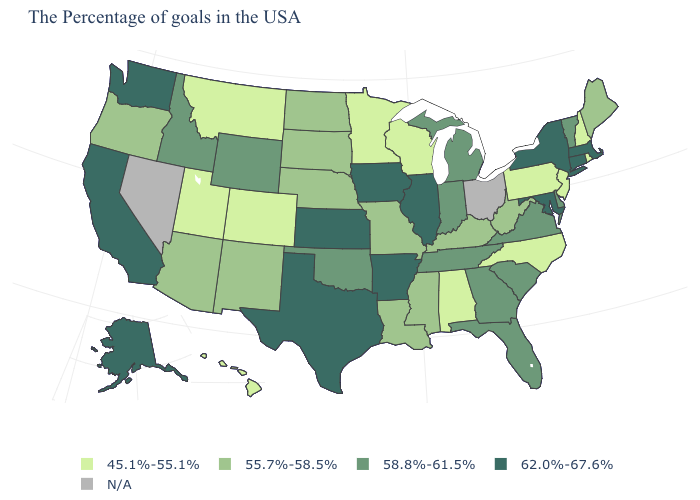Does Illinois have the highest value in the MidWest?
Answer briefly. Yes. Does Utah have the lowest value in the West?
Answer briefly. Yes. What is the value of Kansas?
Quick response, please. 62.0%-67.6%. Which states have the lowest value in the MidWest?
Short answer required. Wisconsin, Minnesota. Name the states that have a value in the range 62.0%-67.6%?
Give a very brief answer. Massachusetts, Connecticut, New York, Maryland, Illinois, Arkansas, Iowa, Kansas, Texas, California, Washington, Alaska. Name the states that have a value in the range 55.7%-58.5%?
Short answer required. Maine, West Virginia, Kentucky, Mississippi, Louisiana, Missouri, Nebraska, South Dakota, North Dakota, New Mexico, Arizona, Oregon. What is the lowest value in states that border New Hampshire?
Answer briefly. 55.7%-58.5%. What is the value of Alabama?
Write a very short answer. 45.1%-55.1%. What is the lowest value in the USA?
Give a very brief answer. 45.1%-55.1%. Which states have the lowest value in the USA?
Be succinct. Rhode Island, New Hampshire, New Jersey, Pennsylvania, North Carolina, Alabama, Wisconsin, Minnesota, Colorado, Utah, Montana, Hawaii. Which states have the lowest value in the West?
Concise answer only. Colorado, Utah, Montana, Hawaii. What is the value of Florida?
Quick response, please. 58.8%-61.5%. What is the value of Kansas?
Concise answer only. 62.0%-67.6%. What is the highest value in the West ?
Concise answer only. 62.0%-67.6%. What is the value of Indiana?
Answer briefly. 58.8%-61.5%. 